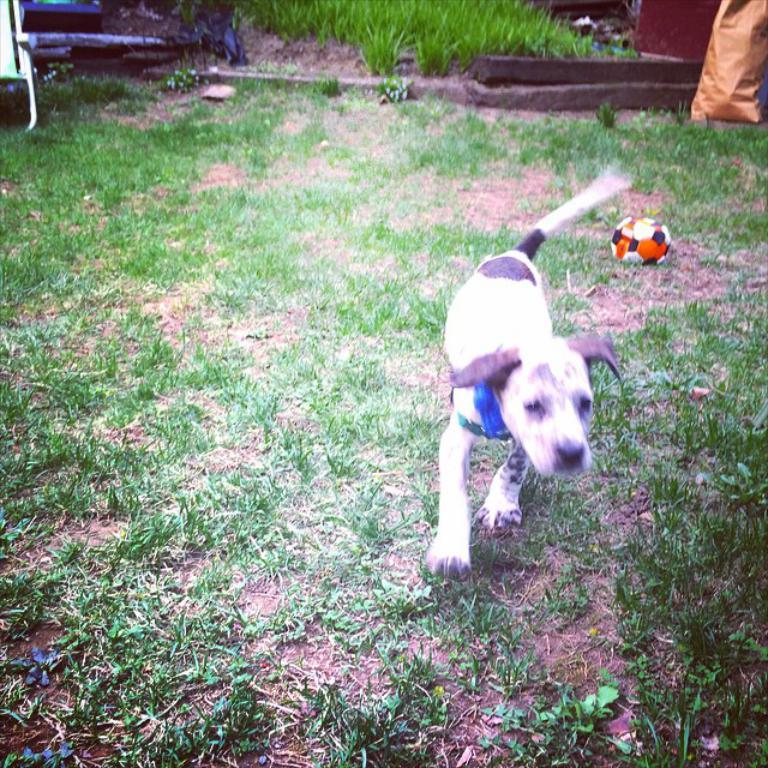What animal can be seen in the image? There is a dog in the image. What is the dog doing in the image? The dog is running. What object is on the ground in the image? There is a ball on the ground in the image. What type of terrain is visible in the image? Grass is present in the image. What other item can be seen in the image? There is a bag in the image. What can be seen in the background of the image? There are plants in the background of the image. How many fairies are flying around the dog in the image? There are no fairies present in the image. What type of men can be seen interacting with the dog in the image? There is no mention of men interacting with the dog in the image. 